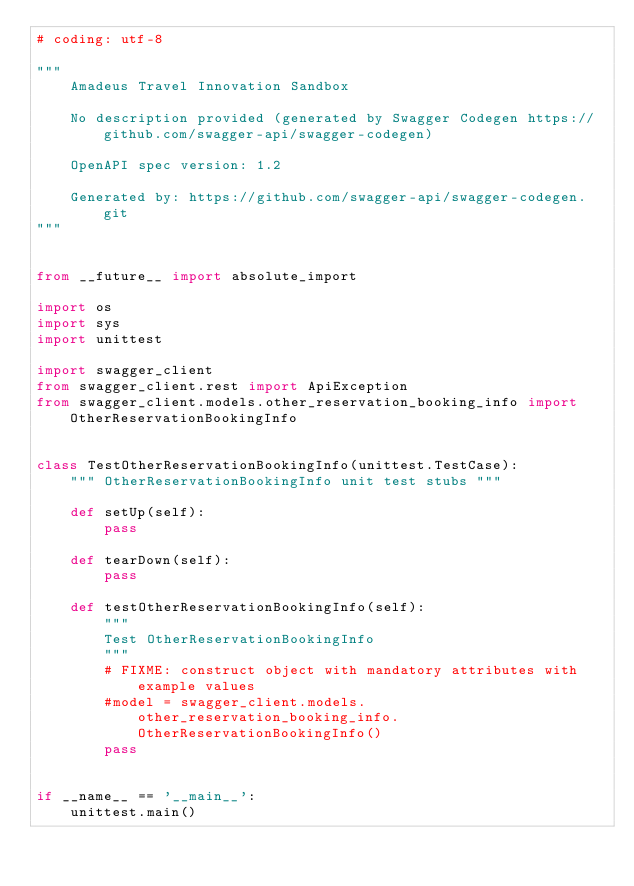<code> <loc_0><loc_0><loc_500><loc_500><_Python_># coding: utf-8

"""
    Amadeus Travel Innovation Sandbox

    No description provided (generated by Swagger Codegen https://github.com/swagger-api/swagger-codegen)

    OpenAPI spec version: 1.2
    
    Generated by: https://github.com/swagger-api/swagger-codegen.git
"""


from __future__ import absolute_import

import os
import sys
import unittest

import swagger_client
from swagger_client.rest import ApiException
from swagger_client.models.other_reservation_booking_info import OtherReservationBookingInfo


class TestOtherReservationBookingInfo(unittest.TestCase):
    """ OtherReservationBookingInfo unit test stubs """

    def setUp(self):
        pass

    def tearDown(self):
        pass

    def testOtherReservationBookingInfo(self):
        """
        Test OtherReservationBookingInfo
        """
        # FIXME: construct object with mandatory attributes with example values
        #model = swagger_client.models.other_reservation_booking_info.OtherReservationBookingInfo()
        pass


if __name__ == '__main__':
    unittest.main()
</code> 